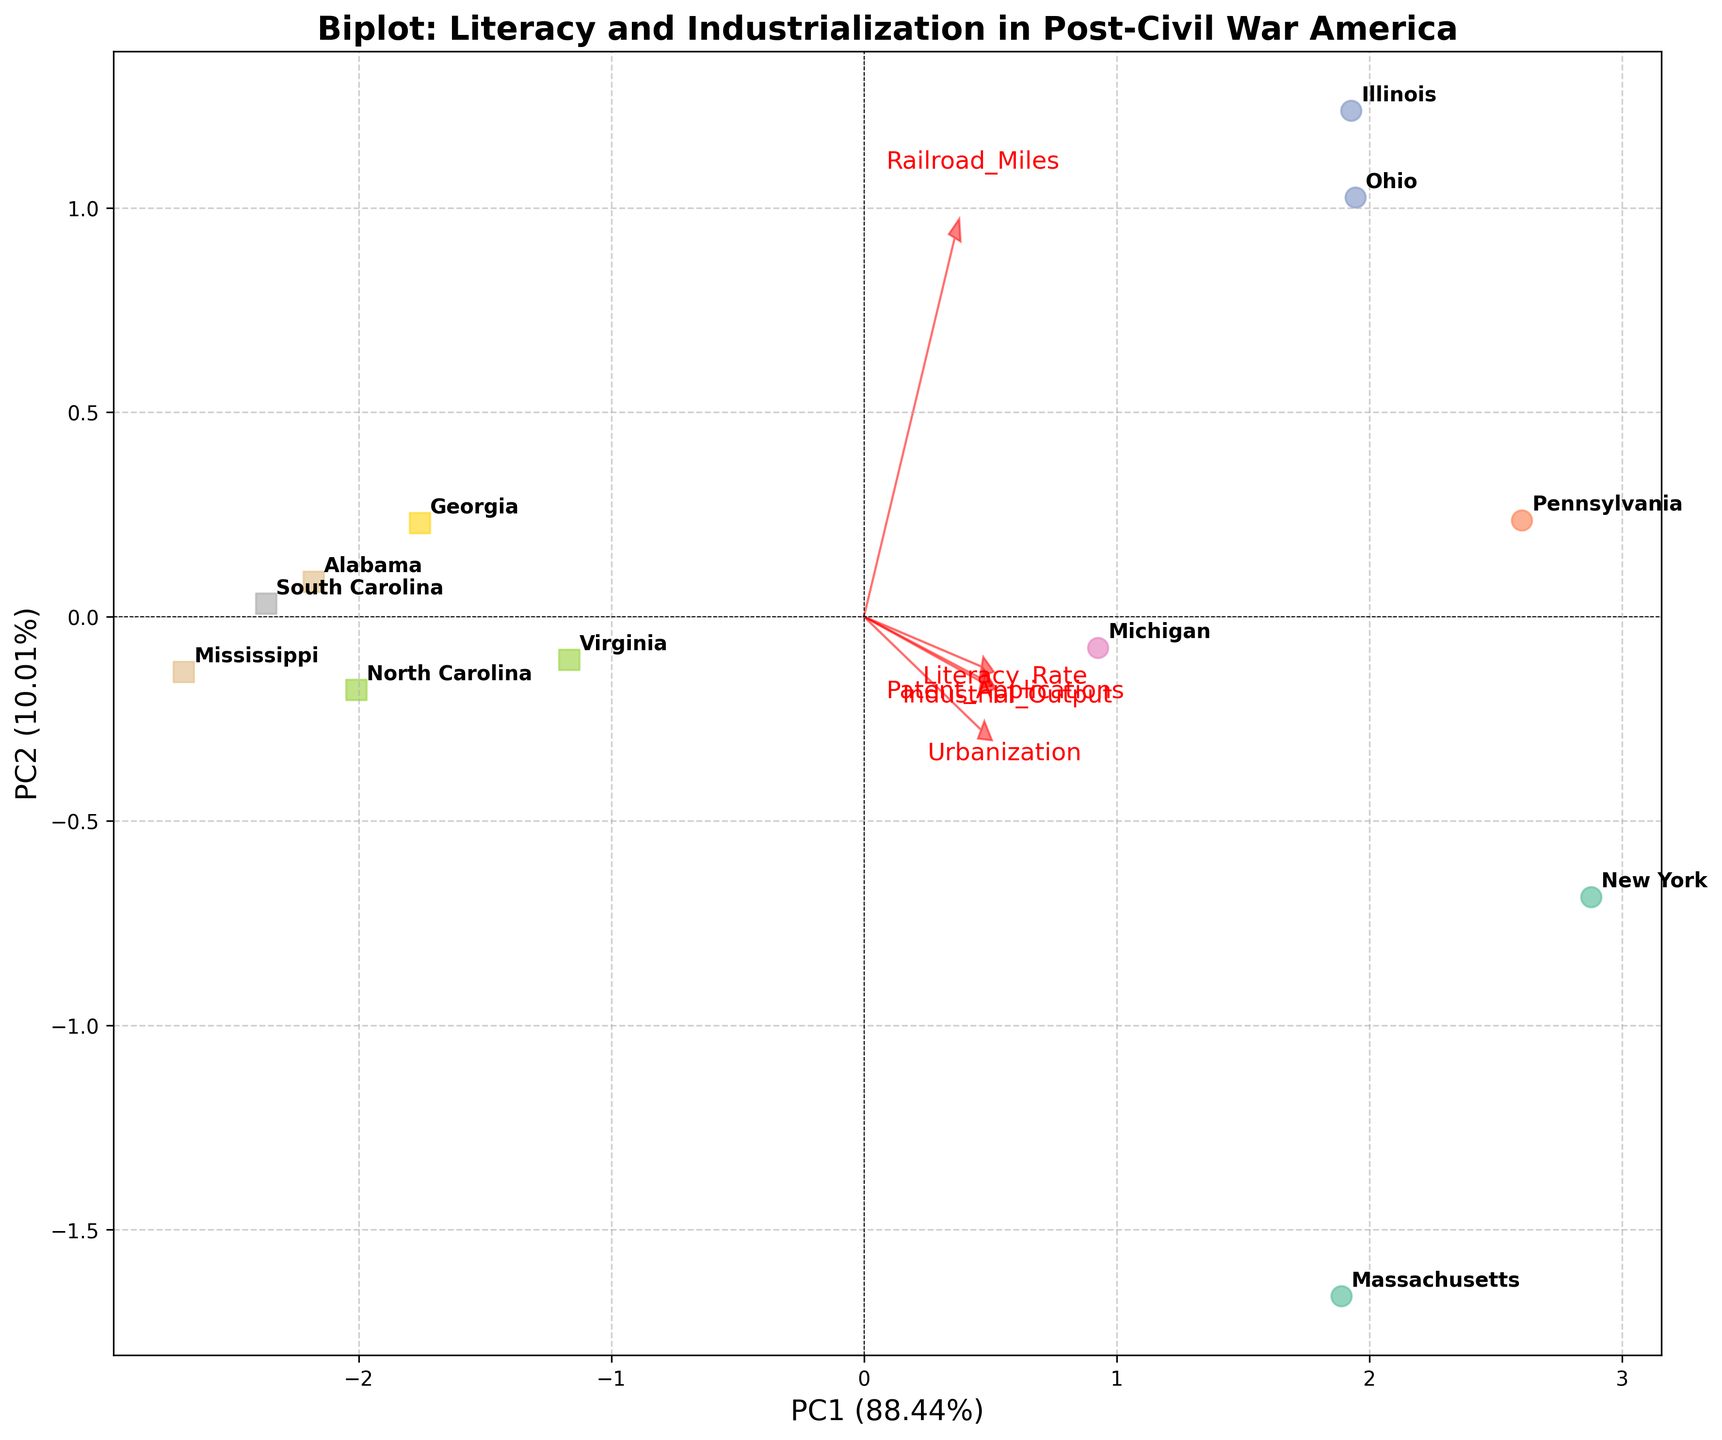How many states are represented in the biplot? Look at the number of labeled points on the figure, each representing a state. Count all the labeled states.
Answer: 12 Which two states have the highest principal component scores on PC1? To find the states with the highest PC1 scores, look for points that are farthest to the right on the x-axis. Identify the labeled states at these positions.
Answer: New York and Pennsylvania What direction does the arrow for "Literacy Rate" point to? Observe the arrow labeled "Literacy Rate" and describe its direction relative to the origin (0,0). Indicate the direction (e.g., upward-right) and any relevant details.
Answer: Upward and to the right Which state is closest to the origin? Locate the point that is nearest to the (0,0) coordinates on the biplot. Identify the state associated with this point.
Answer: South Carolina Which feature appears to be highly correlated with Industrial Output based on the biplot? Look for the arrows that are close to the "Industrial Output" arrow in direction and proximity. Features that point in the same direction as "Industrial Output" indicate a high correlation.
Answer: Patent Applications Which states have negative PC2 scores? Identify the points with negative values on the y-axis (PC2). List the states associated with these points.
Answer: Ohio, Illinois, Michigan, Virginia, North Carolina, Georgia, Alabama, Mississippi What percentage of the variance is explained by PC1 and PC2 combined? Look at the labels of the x-axis and y-axis which indicate the variance explained by PC1 and PC2 respectively. Add these percentages together to find the total variance explained.
Answer: Approximately 75.4% How do the features "Railroad Miles" and "Urbanization" compare in terms of their direction on the biplot? Observe the arrows labeled "Railroad Miles" and "Urbanization". Compare their directions and angles relative to the origin to determine their relationship.
Answer: Similar direction but "Railroad Miles" has a slightly steeper angle Which states have a greater industrial output, Massachusetts or Virginia? Find the points representing Massachusetts and Virginia. Look at their positions relative to the "Industrial Output" arrow to determine which state has a higher value.
Answer: Massachusetts Which state appears to be an outlier based on its placement in the biplot? Examine the relative distances of all the points to identify any points that are significantly separated from the cluster of states. Determine the state associated with this point.
Answer: Virginia 